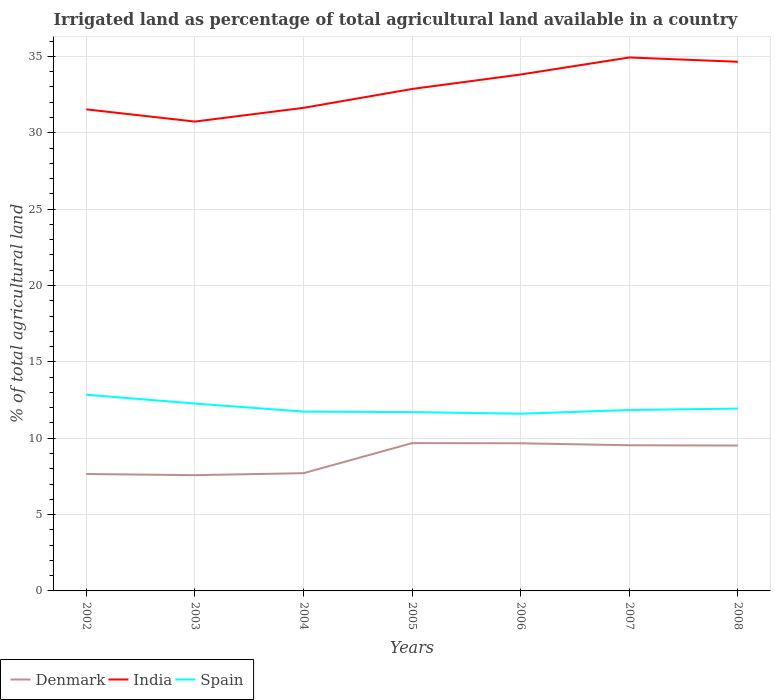How many different coloured lines are there?
Offer a very short reply. 3. Does the line corresponding to Spain intersect with the line corresponding to Denmark?
Your response must be concise. No. Across all years, what is the maximum percentage of irrigated land in Denmark?
Keep it short and to the point. 7.58. In which year was the percentage of irrigated land in India maximum?
Make the answer very short. 2003. What is the total percentage of irrigated land in Denmark in the graph?
Keep it short and to the point. 0.14. What is the difference between the highest and the second highest percentage of irrigated land in Spain?
Offer a very short reply. 1.25. Is the percentage of irrigated land in Spain strictly greater than the percentage of irrigated land in India over the years?
Provide a succinct answer. Yes. How many years are there in the graph?
Make the answer very short. 7. What is the difference between two consecutive major ticks on the Y-axis?
Offer a terse response. 5. Are the values on the major ticks of Y-axis written in scientific E-notation?
Your answer should be very brief. No. Does the graph contain any zero values?
Make the answer very short. No. Does the graph contain grids?
Give a very brief answer. Yes. Where does the legend appear in the graph?
Provide a short and direct response. Bottom left. What is the title of the graph?
Your response must be concise. Irrigated land as percentage of total agricultural land available in a country. Does "Croatia" appear as one of the legend labels in the graph?
Give a very brief answer. No. What is the label or title of the Y-axis?
Give a very brief answer. % of total agricultural land. What is the % of total agricultural land in Denmark in 2002?
Your response must be concise. 7.65. What is the % of total agricultural land of India in 2002?
Keep it short and to the point. 31.53. What is the % of total agricultural land in Spain in 2002?
Your response must be concise. 12.85. What is the % of total agricultural land in Denmark in 2003?
Offer a very short reply. 7.58. What is the % of total agricultural land in India in 2003?
Provide a short and direct response. 30.73. What is the % of total agricultural land in Spain in 2003?
Offer a very short reply. 12.27. What is the % of total agricultural land in Denmark in 2004?
Ensure brevity in your answer.  7.71. What is the % of total agricultural land in India in 2004?
Your response must be concise. 31.63. What is the % of total agricultural land in Spain in 2004?
Offer a terse response. 11.74. What is the % of total agricultural land of Denmark in 2005?
Provide a succinct answer. 9.68. What is the % of total agricultural land in India in 2005?
Your answer should be compact. 32.87. What is the % of total agricultural land of Spain in 2005?
Provide a succinct answer. 11.71. What is the % of total agricultural land of Denmark in 2006?
Provide a succinct answer. 9.67. What is the % of total agricultural land of India in 2006?
Offer a very short reply. 33.82. What is the % of total agricultural land in Spain in 2006?
Your response must be concise. 11.6. What is the % of total agricultural land of Denmark in 2007?
Your response must be concise. 9.54. What is the % of total agricultural land of India in 2007?
Your answer should be compact. 34.93. What is the % of total agricultural land of Spain in 2007?
Offer a very short reply. 11.85. What is the % of total agricultural land in Denmark in 2008?
Your answer should be very brief. 9.52. What is the % of total agricultural land of India in 2008?
Make the answer very short. 34.65. What is the % of total agricultural land of Spain in 2008?
Provide a short and direct response. 11.94. Across all years, what is the maximum % of total agricultural land in Denmark?
Offer a very short reply. 9.68. Across all years, what is the maximum % of total agricultural land of India?
Make the answer very short. 34.93. Across all years, what is the maximum % of total agricultural land in Spain?
Ensure brevity in your answer.  12.85. Across all years, what is the minimum % of total agricultural land of Denmark?
Keep it short and to the point. 7.58. Across all years, what is the minimum % of total agricultural land in India?
Provide a succinct answer. 30.73. Across all years, what is the minimum % of total agricultural land in Spain?
Make the answer very short. 11.6. What is the total % of total agricultural land of Denmark in the graph?
Give a very brief answer. 61.35. What is the total % of total agricultural land in India in the graph?
Keep it short and to the point. 230.17. What is the total % of total agricultural land of Spain in the graph?
Offer a terse response. 83.96. What is the difference between the % of total agricultural land of Denmark in 2002 and that in 2003?
Your answer should be compact. 0.07. What is the difference between the % of total agricultural land of India in 2002 and that in 2003?
Your answer should be very brief. 0.8. What is the difference between the % of total agricultural land of Spain in 2002 and that in 2003?
Make the answer very short. 0.58. What is the difference between the % of total agricultural land in Denmark in 2002 and that in 2004?
Provide a short and direct response. -0.06. What is the difference between the % of total agricultural land in Spain in 2002 and that in 2004?
Make the answer very short. 1.11. What is the difference between the % of total agricultural land in Denmark in 2002 and that in 2005?
Your response must be concise. -2.02. What is the difference between the % of total agricultural land in India in 2002 and that in 2005?
Keep it short and to the point. -1.34. What is the difference between the % of total agricultural land in Spain in 2002 and that in 2005?
Give a very brief answer. 1.14. What is the difference between the % of total agricultural land in Denmark in 2002 and that in 2006?
Keep it short and to the point. -2.01. What is the difference between the % of total agricultural land of India in 2002 and that in 2006?
Keep it short and to the point. -2.28. What is the difference between the % of total agricultural land of Spain in 2002 and that in 2006?
Provide a succinct answer. 1.25. What is the difference between the % of total agricultural land in Denmark in 2002 and that in 2007?
Give a very brief answer. -1.88. What is the difference between the % of total agricultural land in India in 2002 and that in 2007?
Provide a short and direct response. -3.4. What is the difference between the % of total agricultural land of Denmark in 2002 and that in 2008?
Make the answer very short. -1.87. What is the difference between the % of total agricultural land of India in 2002 and that in 2008?
Give a very brief answer. -3.12. What is the difference between the % of total agricultural land in Spain in 2002 and that in 2008?
Offer a terse response. 0.91. What is the difference between the % of total agricultural land in Denmark in 2003 and that in 2004?
Make the answer very short. -0.13. What is the difference between the % of total agricultural land in India in 2003 and that in 2004?
Offer a terse response. -0.9. What is the difference between the % of total agricultural land of Spain in 2003 and that in 2004?
Ensure brevity in your answer.  0.53. What is the difference between the % of total agricultural land of Denmark in 2003 and that in 2005?
Your answer should be compact. -2.1. What is the difference between the % of total agricultural land in India in 2003 and that in 2005?
Offer a very short reply. -2.14. What is the difference between the % of total agricultural land of Spain in 2003 and that in 2005?
Provide a short and direct response. 0.56. What is the difference between the % of total agricultural land of Denmark in 2003 and that in 2006?
Give a very brief answer. -2.09. What is the difference between the % of total agricultural land in India in 2003 and that in 2006?
Provide a short and direct response. -3.08. What is the difference between the % of total agricultural land in Spain in 2003 and that in 2006?
Your answer should be compact. 0.67. What is the difference between the % of total agricultural land of Denmark in 2003 and that in 2007?
Give a very brief answer. -1.96. What is the difference between the % of total agricultural land of India in 2003 and that in 2007?
Offer a terse response. -4.2. What is the difference between the % of total agricultural land in Spain in 2003 and that in 2007?
Ensure brevity in your answer.  0.42. What is the difference between the % of total agricultural land in Denmark in 2003 and that in 2008?
Your answer should be very brief. -1.94. What is the difference between the % of total agricultural land of India in 2003 and that in 2008?
Make the answer very short. -3.92. What is the difference between the % of total agricultural land of Spain in 2003 and that in 2008?
Your answer should be compact. 0.33. What is the difference between the % of total agricultural land of Denmark in 2004 and that in 2005?
Provide a short and direct response. -1.97. What is the difference between the % of total agricultural land in India in 2004 and that in 2005?
Provide a short and direct response. -1.24. What is the difference between the % of total agricultural land in Spain in 2004 and that in 2005?
Make the answer very short. 0.03. What is the difference between the % of total agricultural land in Denmark in 2004 and that in 2006?
Make the answer very short. -1.96. What is the difference between the % of total agricultural land in India in 2004 and that in 2006?
Your answer should be very brief. -2.18. What is the difference between the % of total agricultural land of Spain in 2004 and that in 2006?
Keep it short and to the point. 0.14. What is the difference between the % of total agricultural land in Denmark in 2004 and that in 2007?
Keep it short and to the point. -1.83. What is the difference between the % of total agricultural land in India in 2004 and that in 2007?
Keep it short and to the point. -3.3. What is the difference between the % of total agricultural land in Spain in 2004 and that in 2007?
Your response must be concise. -0.1. What is the difference between the % of total agricultural land in Denmark in 2004 and that in 2008?
Your answer should be compact. -1.81. What is the difference between the % of total agricultural land of India in 2004 and that in 2008?
Offer a terse response. -3.02. What is the difference between the % of total agricultural land of Spain in 2004 and that in 2008?
Keep it short and to the point. -0.2. What is the difference between the % of total agricultural land in Denmark in 2005 and that in 2006?
Provide a succinct answer. 0.01. What is the difference between the % of total agricultural land in India in 2005 and that in 2006?
Your answer should be compact. -0.95. What is the difference between the % of total agricultural land of Spain in 2005 and that in 2006?
Offer a terse response. 0.11. What is the difference between the % of total agricultural land of Denmark in 2005 and that in 2007?
Offer a very short reply. 0.14. What is the difference between the % of total agricultural land in India in 2005 and that in 2007?
Provide a succinct answer. -2.06. What is the difference between the % of total agricultural land in Spain in 2005 and that in 2007?
Make the answer very short. -0.14. What is the difference between the % of total agricultural land of Denmark in 2005 and that in 2008?
Your response must be concise. 0.16. What is the difference between the % of total agricultural land of India in 2005 and that in 2008?
Offer a very short reply. -1.78. What is the difference between the % of total agricultural land of Spain in 2005 and that in 2008?
Your response must be concise. -0.23. What is the difference between the % of total agricultural land of Denmark in 2006 and that in 2007?
Your answer should be very brief. 0.13. What is the difference between the % of total agricultural land of India in 2006 and that in 2007?
Provide a short and direct response. -1.12. What is the difference between the % of total agricultural land of Spain in 2006 and that in 2007?
Your answer should be compact. -0.25. What is the difference between the % of total agricultural land of Denmark in 2006 and that in 2008?
Offer a terse response. 0.15. What is the difference between the % of total agricultural land in India in 2006 and that in 2008?
Provide a succinct answer. -0.83. What is the difference between the % of total agricultural land of Spain in 2006 and that in 2008?
Your response must be concise. -0.34. What is the difference between the % of total agricultural land in Denmark in 2007 and that in 2008?
Provide a succinct answer. 0.02. What is the difference between the % of total agricultural land of India in 2007 and that in 2008?
Provide a succinct answer. 0.28. What is the difference between the % of total agricultural land of Spain in 2007 and that in 2008?
Keep it short and to the point. -0.09. What is the difference between the % of total agricultural land of Denmark in 2002 and the % of total agricultural land of India in 2003?
Ensure brevity in your answer.  -23.08. What is the difference between the % of total agricultural land in Denmark in 2002 and the % of total agricultural land in Spain in 2003?
Provide a succinct answer. -4.62. What is the difference between the % of total agricultural land in India in 2002 and the % of total agricultural land in Spain in 2003?
Give a very brief answer. 19.26. What is the difference between the % of total agricultural land of Denmark in 2002 and the % of total agricultural land of India in 2004?
Provide a short and direct response. -23.98. What is the difference between the % of total agricultural land of Denmark in 2002 and the % of total agricultural land of Spain in 2004?
Keep it short and to the point. -4.09. What is the difference between the % of total agricultural land in India in 2002 and the % of total agricultural land in Spain in 2004?
Your answer should be compact. 19.79. What is the difference between the % of total agricultural land of Denmark in 2002 and the % of total agricultural land of India in 2005?
Make the answer very short. -25.21. What is the difference between the % of total agricultural land in Denmark in 2002 and the % of total agricultural land in Spain in 2005?
Your response must be concise. -4.05. What is the difference between the % of total agricultural land in India in 2002 and the % of total agricultural land in Spain in 2005?
Provide a short and direct response. 19.82. What is the difference between the % of total agricultural land in Denmark in 2002 and the % of total agricultural land in India in 2006?
Make the answer very short. -26.16. What is the difference between the % of total agricultural land of Denmark in 2002 and the % of total agricultural land of Spain in 2006?
Give a very brief answer. -3.95. What is the difference between the % of total agricultural land in India in 2002 and the % of total agricultural land in Spain in 2006?
Ensure brevity in your answer.  19.93. What is the difference between the % of total agricultural land of Denmark in 2002 and the % of total agricultural land of India in 2007?
Provide a short and direct response. -27.28. What is the difference between the % of total agricultural land of Denmark in 2002 and the % of total agricultural land of Spain in 2007?
Offer a very short reply. -4.19. What is the difference between the % of total agricultural land in India in 2002 and the % of total agricultural land in Spain in 2007?
Give a very brief answer. 19.68. What is the difference between the % of total agricultural land of Denmark in 2002 and the % of total agricultural land of India in 2008?
Give a very brief answer. -27. What is the difference between the % of total agricultural land of Denmark in 2002 and the % of total agricultural land of Spain in 2008?
Your answer should be very brief. -4.28. What is the difference between the % of total agricultural land in India in 2002 and the % of total agricultural land in Spain in 2008?
Your answer should be very brief. 19.59. What is the difference between the % of total agricultural land in Denmark in 2003 and the % of total agricultural land in India in 2004?
Your response must be concise. -24.05. What is the difference between the % of total agricultural land of Denmark in 2003 and the % of total agricultural land of Spain in 2004?
Offer a terse response. -4.16. What is the difference between the % of total agricultural land of India in 2003 and the % of total agricultural land of Spain in 2004?
Provide a short and direct response. 18.99. What is the difference between the % of total agricultural land of Denmark in 2003 and the % of total agricultural land of India in 2005?
Your answer should be compact. -25.29. What is the difference between the % of total agricultural land in Denmark in 2003 and the % of total agricultural land in Spain in 2005?
Offer a terse response. -4.13. What is the difference between the % of total agricultural land of India in 2003 and the % of total agricultural land of Spain in 2005?
Offer a very short reply. 19.02. What is the difference between the % of total agricultural land in Denmark in 2003 and the % of total agricultural land in India in 2006?
Offer a very short reply. -26.24. What is the difference between the % of total agricultural land in Denmark in 2003 and the % of total agricultural land in Spain in 2006?
Ensure brevity in your answer.  -4.02. What is the difference between the % of total agricultural land of India in 2003 and the % of total agricultural land of Spain in 2006?
Provide a short and direct response. 19.13. What is the difference between the % of total agricultural land in Denmark in 2003 and the % of total agricultural land in India in 2007?
Give a very brief answer. -27.35. What is the difference between the % of total agricultural land in Denmark in 2003 and the % of total agricultural land in Spain in 2007?
Give a very brief answer. -4.27. What is the difference between the % of total agricultural land in India in 2003 and the % of total agricultural land in Spain in 2007?
Your answer should be very brief. 18.89. What is the difference between the % of total agricultural land of Denmark in 2003 and the % of total agricultural land of India in 2008?
Ensure brevity in your answer.  -27.07. What is the difference between the % of total agricultural land of Denmark in 2003 and the % of total agricultural land of Spain in 2008?
Offer a very short reply. -4.36. What is the difference between the % of total agricultural land of India in 2003 and the % of total agricultural land of Spain in 2008?
Ensure brevity in your answer.  18.79. What is the difference between the % of total agricultural land of Denmark in 2004 and the % of total agricultural land of India in 2005?
Provide a succinct answer. -25.16. What is the difference between the % of total agricultural land in Denmark in 2004 and the % of total agricultural land in Spain in 2005?
Your answer should be compact. -4. What is the difference between the % of total agricultural land of India in 2004 and the % of total agricultural land of Spain in 2005?
Ensure brevity in your answer.  19.92. What is the difference between the % of total agricultural land of Denmark in 2004 and the % of total agricultural land of India in 2006?
Provide a short and direct response. -26.11. What is the difference between the % of total agricultural land of Denmark in 2004 and the % of total agricultural land of Spain in 2006?
Keep it short and to the point. -3.89. What is the difference between the % of total agricultural land in India in 2004 and the % of total agricultural land in Spain in 2006?
Offer a terse response. 20.03. What is the difference between the % of total agricultural land of Denmark in 2004 and the % of total agricultural land of India in 2007?
Provide a succinct answer. -27.22. What is the difference between the % of total agricultural land in Denmark in 2004 and the % of total agricultural land in Spain in 2007?
Make the answer very short. -4.14. What is the difference between the % of total agricultural land in India in 2004 and the % of total agricultural land in Spain in 2007?
Your answer should be compact. 19.78. What is the difference between the % of total agricultural land of Denmark in 2004 and the % of total agricultural land of India in 2008?
Offer a very short reply. -26.94. What is the difference between the % of total agricultural land in Denmark in 2004 and the % of total agricultural land in Spain in 2008?
Make the answer very short. -4.23. What is the difference between the % of total agricultural land in India in 2004 and the % of total agricultural land in Spain in 2008?
Keep it short and to the point. 19.69. What is the difference between the % of total agricultural land of Denmark in 2005 and the % of total agricultural land of India in 2006?
Your response must be concise. -24.14. What is the difference between the % of total agricultural land in Denmark in 2005 and the % of total agricultural land in Spain in 2006?
Ensure brevity in your answer.  -1.92. What is the difference between the % of total agricultural land in India in 2005 and the % of total agricultural land in Spain in 2006?
Make the answer very short. 21.27. What is the difference between the % of total agricultural land in Denmark in 2005 and the % of total agricultural land in India in 2007?
Keep it short and to the point. -25.25. What is the difference between the % of total agricultural land of Denmark in 2005 and the % of total agricultural land of Spain in 2007?
Your answer should be compact. -2.17. What is the difference between the % of total agricultural land of India in 2005 and the % of total agricultural land of Spain in 2007?
Your answer should be compact. 21.02. What is the difference between the % of total agricultural land of Denmark in 2005 and the % of total agricultural land of India in 2008?
Your response must be concise. -24.97. What is the difference between the % of total agricultural land in Denmark in 2005 and the % of total agricultural land in Spain in 2008?
Offer a very short reply. -2.26. What is the difference between the % of total agricultural land in India in 2005 and the % of total agricultural land in Spain in 2008?
Offer a very short reply. 20.93. What is the difference between the % of total agricultural land in Denmark in 2006 and the % of total agricultural land in India in 2007?
Keep it short and to the point. -25.26. What is the difference between the % of total agricultural land of Denmark in 2006 and the % of total agricultural land of Spain in 2007?
Your response must be concise. -2.18. What is the difference between the % of total agricultural land of India in 2006 and the % of total agricultural land of Spain in 2007?
Ensure brevity in your answer.  21.97. What is the difference between the % of total agricultural land of Denmark in 2006 and the % of total agricultural land of India in 2008?
Keep it short and to the point. -24.98. What is the difference between the % of total agricultural land in Denmark in 2006 and the % of total agricultural land in Spain in 2008?
Ensure brevity in your answer.  -2.27. What is the difference between the % of total agricultural land in India in 2006 and the % of total agricultural land in Spain in 2008?
Offer a terse response. 21.88. What is the difference between the % of total agricultural land of Denmark in 2007 and the % of total agricultural land of India in 2008?
Offer a very short reply. -25.11. What is the difference between the % of total agricultural land of Denmark in 2007 and the % of total agricultural land of Spain in 2008?
Offer a very short reply. -2.4. What is the difference between the % of total agricultural land in India in 2007 and the % of total agricultural land in Spain in 2008?
Give a very brief answer. 22.99. What is the average % of total agricultural land of Denmark per year?
Give a very brief answer. 8.76. What is the average % of total agricultural land of India per year?
Offer a very short reply. 32.88. What is the average % of total agricultural land of Spain per year?
Keep it short and to the point. 11.99. In the year 2002, what is the difference between the % of total agricultural land of Denmark and % of total agricultural land of India?
Provide a succinct answer. -23.88. In the year 2002, what is the difference between the % of total agricultural land in Denmark and % of total agricultural land in Spain?
Your response must be concise. -5.19. In the year 2002, what is the difference between the % of total agricultural land of India and % of total agricultural land of Spain?
Give a very brief answer. 18.68. In the year 2003, what is the difference between the % of total agricultural land of Denmark and % of total agricultural land of India?
Provide a succinct answer. -23.15. In the year 2003, what is the difference between the % of total agricultural land of Denmark and % of total agricultural land of Spain?
Provide a succinct answer. -4.69. In the year 2003, what is the difference between the % of total agricultural land of India and % of total agricultural land of Spain?
Keep it short and to the point. 18.46. In the year 2004, what is the difference between the % of total agricultural land in Denmark and % of total agricultural land in India?
Your response must be concise. -23.92. In the year 2004, what is the difference between the % of total agricultural land of Denmark and % of total agricultural land of Spain?
Make the answer very short. -4.03. In the year 2004, what is the difference between the % of total agricultural land of India and % of total agricultural land of Spain?
Provide a short and direct response. 19.89. In the year 2005, what is the difference between the % of total agricultural land in Denmark and % of total agricultural land in India?
Your answer should be very brief. -23.19. In the year 2005, what is the difference between the % of total agricultural land in Denmark and % of total agricultural land in Spain?
Your answer should be very brief. -2.03. In the year 2005, what is the difference between the % of total agricultural land of India and % of total agricultural land of Spain?
Keep it short and to the point. 21.16. In the year 2006, what is the difference between the % of total agricultural land of Denmark and % of total agricultural land of India?
Offer a very short reply. -24.15. In the year 2006, what is the difference between the % of total agricultural land of Denmark and % of total agricultural land of Spain?
Make the answer very short. -1.94. In the year 2006, what is the difference between the % of total agricultural land in India and % of total agricultural land in Spain?
Ensure brevity in your answer.  22.21. In the year 2007, what is the difference between the % of total agricultural land of Denmark and % of total agricultural land of India?
Your answer should be compact. -25.39. In the year 2007, what is the difference between the % of total agricultural land of Denmark and % of total agricultural land of Spain?
Provide a succinct answer. -2.31. In the year 2007, what is the difference between the % of total agricultural land of India and % of total agricultural land of Spain?
Your answer should be compact. 23.08. In the year 2008, what is the difference between the % of total agricultural land of Denmark and % of total agricultural land of India?
Provide a short and direct response. -25.13. In the year 2008, what is the difference between the % of total agricultural land in Denmark and % of total agricultural land in Spain?
Give a very brief answer. -2.42. In the year 2008, what is the difference between the % of total agricultural land in India and % of total agricultural land in Spain?
Ensure brevity in your answer.  22.71. What is the ratio of the % of total agricultural land in Denmark in 2002 to that in 2003?
Give a very brief answer. 1.01. What is the ratio of the % of total agricultural land in Spain in 2002 to that in 2003?
Provide a short and direct response. 1.05. What is the ratio of the % of total agricultural land in Denmark in 2002 to that in 2004?
Offer a very short reply. 0.99. What is the ratio of the % of total agricultural land of Spain in 2002 to that in 2004?
Your answer should be very brief. 1.09. What is the ratio of the % of total agricultural land in Denmark in 2002 to that in 2005?
Offer a terse response. 0.79. What is the ratio of the % of total agricultural land in India in 2002 to that in 2005?
Your answer should be compact. 0.96. What is the ratio of the % of total agricultural land in Spain in 2002 to that in 2005?
Your answer should be compact. 1.1. What is the ratio of the % of total agricultural land in Denmark in 2002 to that in 2006?
Your answer should be very brief. 0.79. What is the ratio of the % of total agricultural land in India in 2002 to that in 2006?
Your response must be concise. 0.93. What is the ratio of the % of total agricultural land in Spain in 2002 to that in 2006?
Offer a very short reply. 1.11. What is the ratio of the % of total agricultural land in Denmark in 2002 to that in 2007?
Ensure brevity in your answer.  0.8. What is the ratio of the % of total agricultural land in India in 2002 to that in 2007?
Your answer should be very brief. 0.9. What is the ratio of the % of total agricultural land of Spain in 2002 to that in 2007?
Your response must be concise. 1.08. What is the ratio of the % of total agricultural land of Denmark in 2002 to that in 2008?
Provide a succinct answer. 0.8. What is the ratio of the % of total agricultural land of India in 2002 to that in 2008?
Ensure brevity in your answer.  0.91. What is the ratio of the % of total agricultural land of Spain in 2002 to that in 2008?
Your answer should be very brief. 1.08. What is the ratio of the % of total agricultural land in Denmark in 2003 to that in 2004?
Your answer should be very brief. 0.98. What is the ratio of the % of total agricultural land in India in 2003 to that in 2004?
Provide a short and direct response. 0.97. What is the ratio of the % of total agricultural land of Spain in 2003 to that in 2004?
Offer a terse response. 1.04. What is the ratio of the % of total agricultural land in Denmark in 2003 to that in 2005?
Offer a very short reply. 0.78. What is the ratio of the % of total agricultural land of India in 2003 to that in 2005?
Offer a very short reply. 0.94. What is the ratio of the % of total agricultural land of Spain in 2003 to that in 2005?
Your response must be concise. 1.05. What is the ratio of the % of total agricultural land in Denmark in 2003 to that in 2006?
Your response must be concise. 0.78. What is the ratio of the % of total agricultural land of India in 2003 to that in 2006?
Your answer should be compact. 0.91. What is the ratio of the % of total agricultural land in Spain in 2003 to that in 2006?
Your response must be concise. 1.06. What is the ratio of the % of total agricultural land in Denmark in 2003 to that in 2007?
Offer a terse response. 0.79. What is the ratio of the % of total agricultural land of India in 2003 to that in 2007?
Offer a terse response. 0.88. What is the ratio of the % of total agricultural land in Spain in 2003 to that in 2007?
Your answer should be compact. 1.04. What is the ratio of the % of total agricultural land in Denmark in 2003 to that in 2008?
Offer a very short reply. 0.8. What is the ratio of the % of total agricultural land in India in 2003 to that in 2008?
Provide a short and direct response. 0.89. What is the ratio of the % of total agricultural land of Spain in 2003 to that in 2008?
Give a very brief answer. 1.03. What is the ratio of the % of total agricultural land in Denmark in 2004 to that in 2005?
Give a very brief answer. 0.8. What is the ratio of the % of total agricultural land of India in 2004 to that in 2005?
Your answer should be very brief. 0.96. What is the ratio of the % of total agricultural land in Denmark in 2004 to that in 2006?
Provide a succinct answer. 0.8. What is the ratio of the % of total agricultural land of India in 2004 to that in 2006?
Ensure brevity in your answer.  0.94. What is the ratio of the % of total agricultural land in Spain in 2004 to that in 2006?
Provide a short and direct response. 1.01. What is the ratio of the % of total agricultural land in Denmark in 2004 to that in 2007?
Your answer should be very brief. 0.81. What is the ratio of the % of total agricultural land of India in 2004 to that in 2007?
Your answer should be compact. 0.91. What is the ratio of the % of total agricultural land in Denmark in 2004 to that in 2008?
Your answer should be compact. 0.81. What is the ratio of the % of total agricultural land in India in 2004 to that in 2008?
Give a very brief answer. 0.91. What is the ratio of the % of total agricultural land of Spain in 2004 to that in 2008?
Give a very brief answer. 0.98. What is the ratio of the % of total agricultural land of Spain in 2005 to that in 2006?
Provide a succinct answer. 1.01. What is the ratio of the % of total agricultural land of Denmark in 2005 to that in 2007?
Keep it short and to the point. 1.01. What is the ratio of the % of total agricultural land of India in 2005 to that in 2007?
Your answer should be very brief. 0.94. What is the ratio of the % of total agricultural land of Spain in 2005 to that in 2007?
Provide a succinct answer. 0.99. What is the ratio of the % of total agricultural land in Denmark in 2005 to that in 2008?
Make the answer very short. 1.02. What is the ratio of the % of total agricultural land in India in 2005 to that in 2008?
Ensure brevity in your answer.  0.95. What is the ratio of the % of total agricultural land in Spain in 2005 to that in 2008?
Your answer should be very brief. 0.98. What is the ratio of the % of total agricultural land in Denmark in 2006 to that in 2007?
Keep it short and to the point. 1.01. What is the ratio of the % of total agricultural land of India in 2006 to that in 2007?
Your answer should be very brief. 0.97. What is the ratio of the % of total agricultural land of Spain in 2006 to that in 2007?
Your answer should be compact. 0.98. What is the ratio of the % of total agricultural land in Denmark in 2006 to that in 2008?
Ensure brevity in your answer.  1.02. What is the ratio of the % of total agricultural land of India in 2006 to that in 2008?
Offer a terse response. 0.98. What is the ratio of the % of total agricultural land of Spain in 2006 to that in 2008?
Ensure brevity in your answer.  0.97. What is the difference between the highest and the second highest % of total agricultural land of Denmark?
Your answer should be very brief. 0.01. What is the difference between the highest and the second highest % of total agricultural land of India?
Give a very brief answer. 0.28. What is the difference between the highest and the second highest % of total agricultural land of Spain?
Your answer should be compact. 0.58. What is the difference between the highest and the lowest % of total agricultural land in Denmark?
Offer a very short reply. 2.1. What is the difference between the highest and the lowest % of total agricultural land of India?
Provide a succinct answer. 4.2. What is the difference between the highest and the lowest % of total agricultural land of Spain?
Provide a succinct answer. 1.25. 